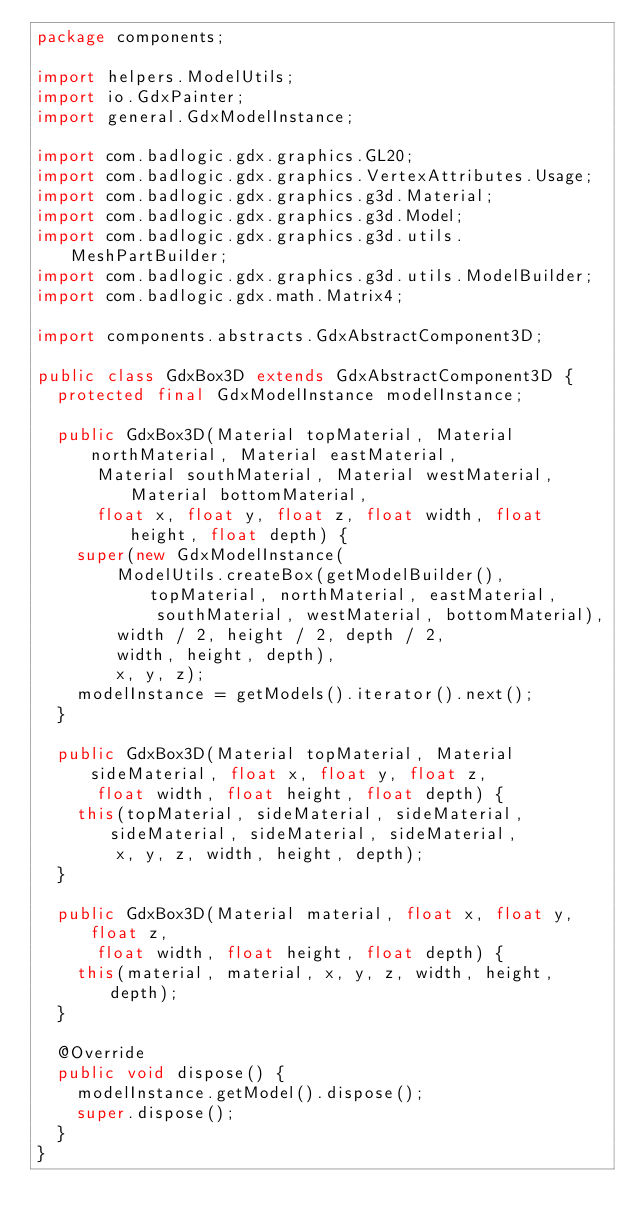Convert code to text. <code><loc_0><loc_0><loc_500><loc_500><_Java_>package components;

import helpers.ModelUtils;
import io.GdxPainter;
import general.GdxModelInstance;

import com.badlogic.gdx.graphics.GL20;
import com.badlogic.gdx.graphics.VertexAttributes.Usage;
import com.badlogic.gdx.graphics.g3d.Material;
import com.badlogic.gdx.graphics.g3d.Model;
import com.badlogic.gdx.graphics.g3d.utils.MeshPartBuilder;
import com.badlogic.gdx.graphics.g3d.utils.ModelBuilder;
import com.badlogic.gdx.math.Matrix4;

import components.abstracts.GdxAbstractComponent3D;

public class GdxBox3D extends GdxAbstractComponent3D {
  protected final GdxModelInstance modelInstance;
  
  public GdxBox3D(Material topMaterial, Material northMaterial, Material eastMaterial, 
      Material southMaterial, Material westMaterial, Material bottomMaterial, 
      float x, float y, float z, float width, float height, float depth) {
    super(new GdxModelInstance(
        ModelUtils.createBox(getModelBuilder(), topMaterial, northMaterial, eastMaterial, 
            southMaterial, westMaterial, bottomMaterial), 
        width / 2, height / 2, depth / 2, 
        width, height, depth),
        x, y, z);
    modelInstance = getModels().iterator().next();
  }
  
  public GdxBox3D(Material topMaterial, Material sideMaterial, float x, float y, float z, 
      float width, float height, float depth) {
    this(topMaterial, sideMaterial, sideMaterial, sideMaterial, sideMaterial, sideMaterial, 
        x, y, z, width, height, depth);
  }
  
  public GdxBox3D(Material material, float x, float y, float z, 
      float width, float height, float depth) {
    this(material, material, x, y, z, width, height, depth);
  }

  @Override
  public void dispose() {
    modelInstance.getModel().dispose();
    super.dispose();
  }
}
</code> 